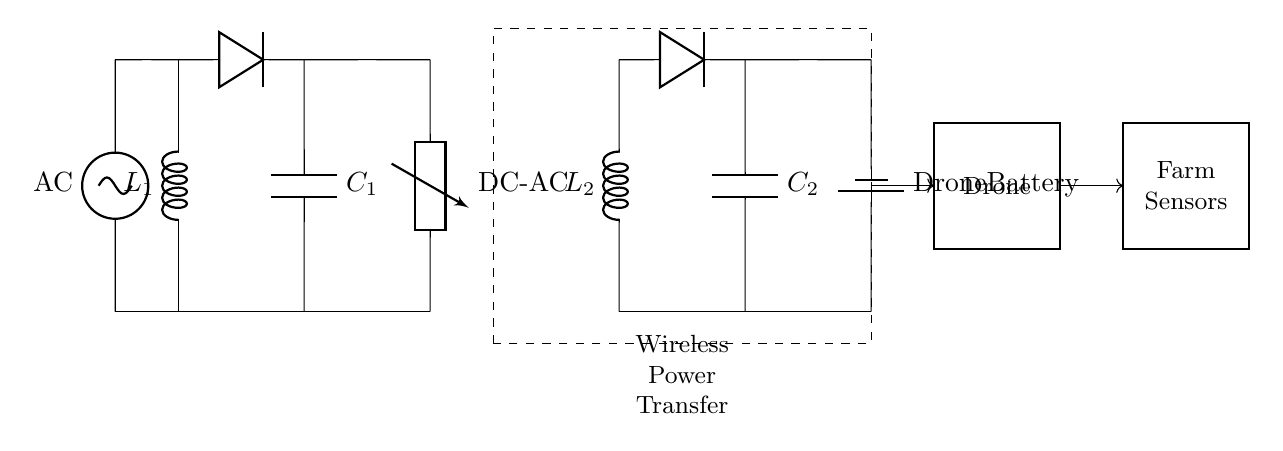What is the type of primary component used for energy transfer? The primary component used for energy transfer in this diagram is the inductor labeled L1, which is part of the wireless charging system. Inductors are crucial for creating the magnetic field necessary for wireless power transfer.
Answer: Inductor What does the dashed rectangle represent in the circuit? The dashed rectangle represents the wireless power transfer system, indicating the area where energy is transferred from the primary side to the secondary side without physical connections. This aligns with the concept of induction used in wireless charging applications.
Answer: Wireless Power Transfer How many capacitors are included in the circuit? There are two capacitors in the circuit: C1 and C2, which are used for smoothing rectified voltage and storing energy for the secondary side respectively. Capacitors play a crucial role in stabilizing voltage levels in power circuits.
Answer: Two What is the labeled voltage source in the circuit? The labeled voltage source in the circuit is an alternating current source represented as AC. This source provides the necessary current for the operation of the charging system and is essential for the primary coil to create a magnetic field.
Answer: AC Which component converts DC to AC in the circuit? The component that converts direct current to alternating current is the device labeled "DC-AC." This process is important for wireless charging systems where alternating current is required to generate a changing magnetic field necessary for the secondary coil to receive energy effectively.
Answer: DC-AC What is the final component connected to the drone in the circuit? The final component connected to the drone is the drone battery, which stores energy from the wireless charging system and powers the drone's operations during monitoring tasks on the farm. Without this battery, the drone would not have a power source to operate.
Answer: Drone Battery Which two components form the rectifier system in the circuit? The rectifier system consists of diodes connected to both capacitors, C1 and C2. The diodes are essential for converting the alternating current generated to direct current, allowing the battery to charge effectively. The combined operation of the diodes and capacitors allows for efficient rectification in this wireless charging setup.
Answer: Diodes and Capacitors 